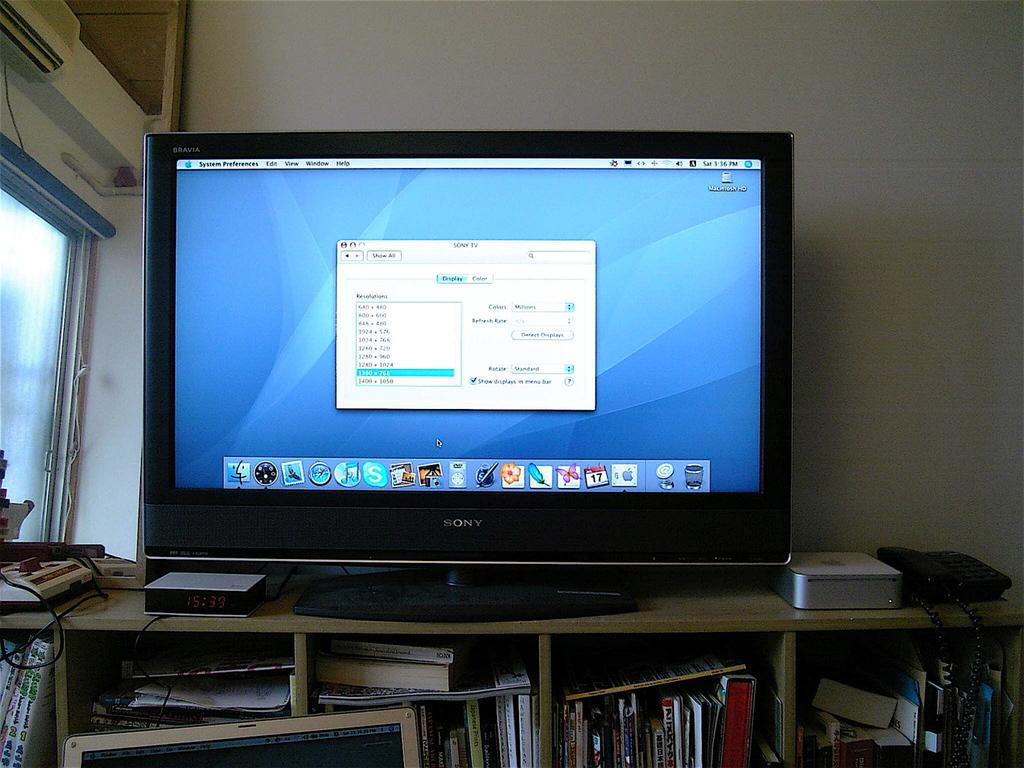<image>
Give a short and clear explanation of the subsequent image. A sony monitor is displaying a computer screen on it. 